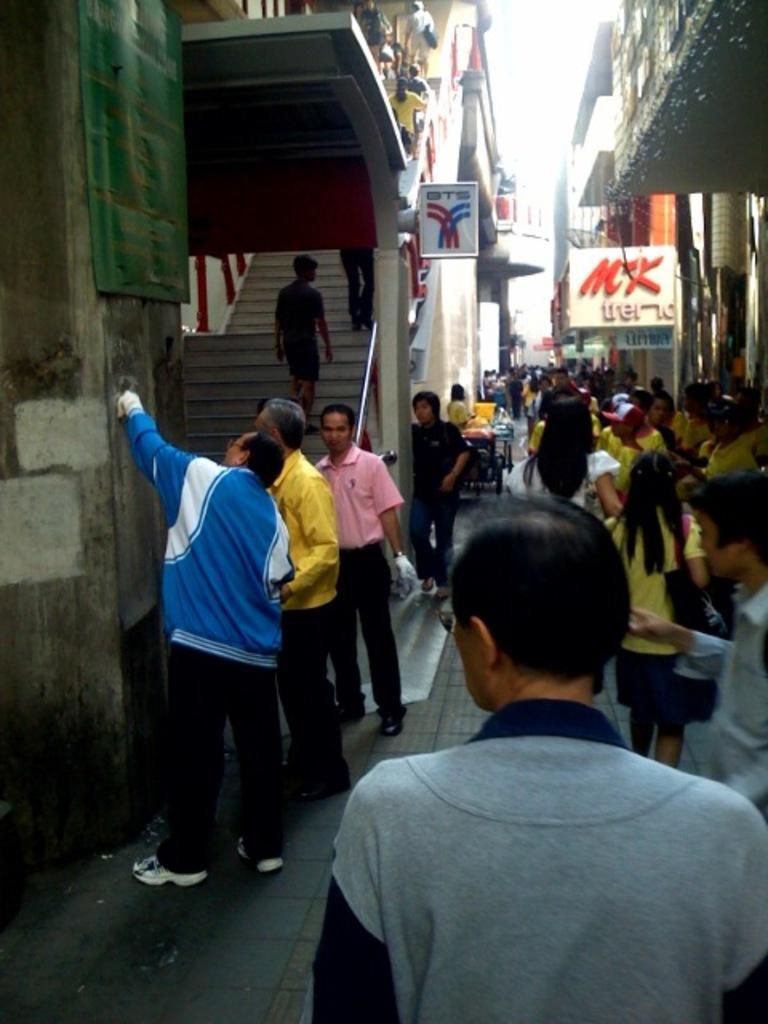How would you summarize this image in a sentence or two? In this picture we can see a group of people and in the background we can see buildings,name boards. 